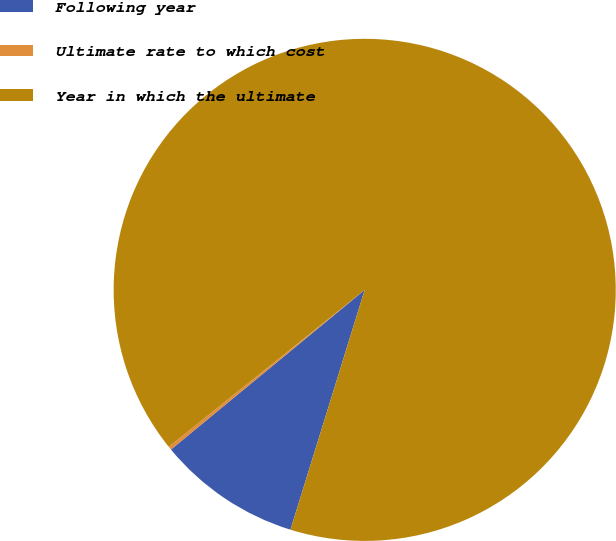Convert chart. <chart><loc_0><loc_0><loc_500><loc_500><pie_chart><fcel>Following year<fcel>Ultimate rate to which cost<fcel>Year in which the ultimate<nl><fcel>9.25%<fcel>0.22%<fcel>90.52%<nl></chart> 